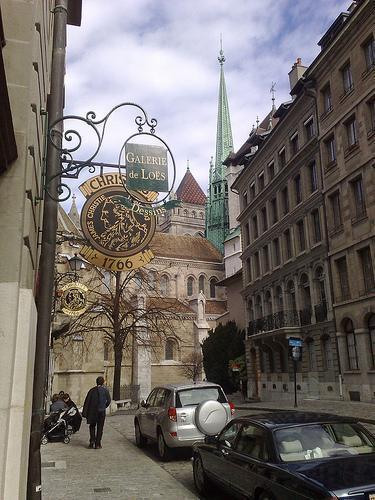How many cars are in this photo?
Give a very brief answer. 2. How many people are walking?
Give a very brief answer. 1. How many signs are visible?
Give a very brief answer. 3. 